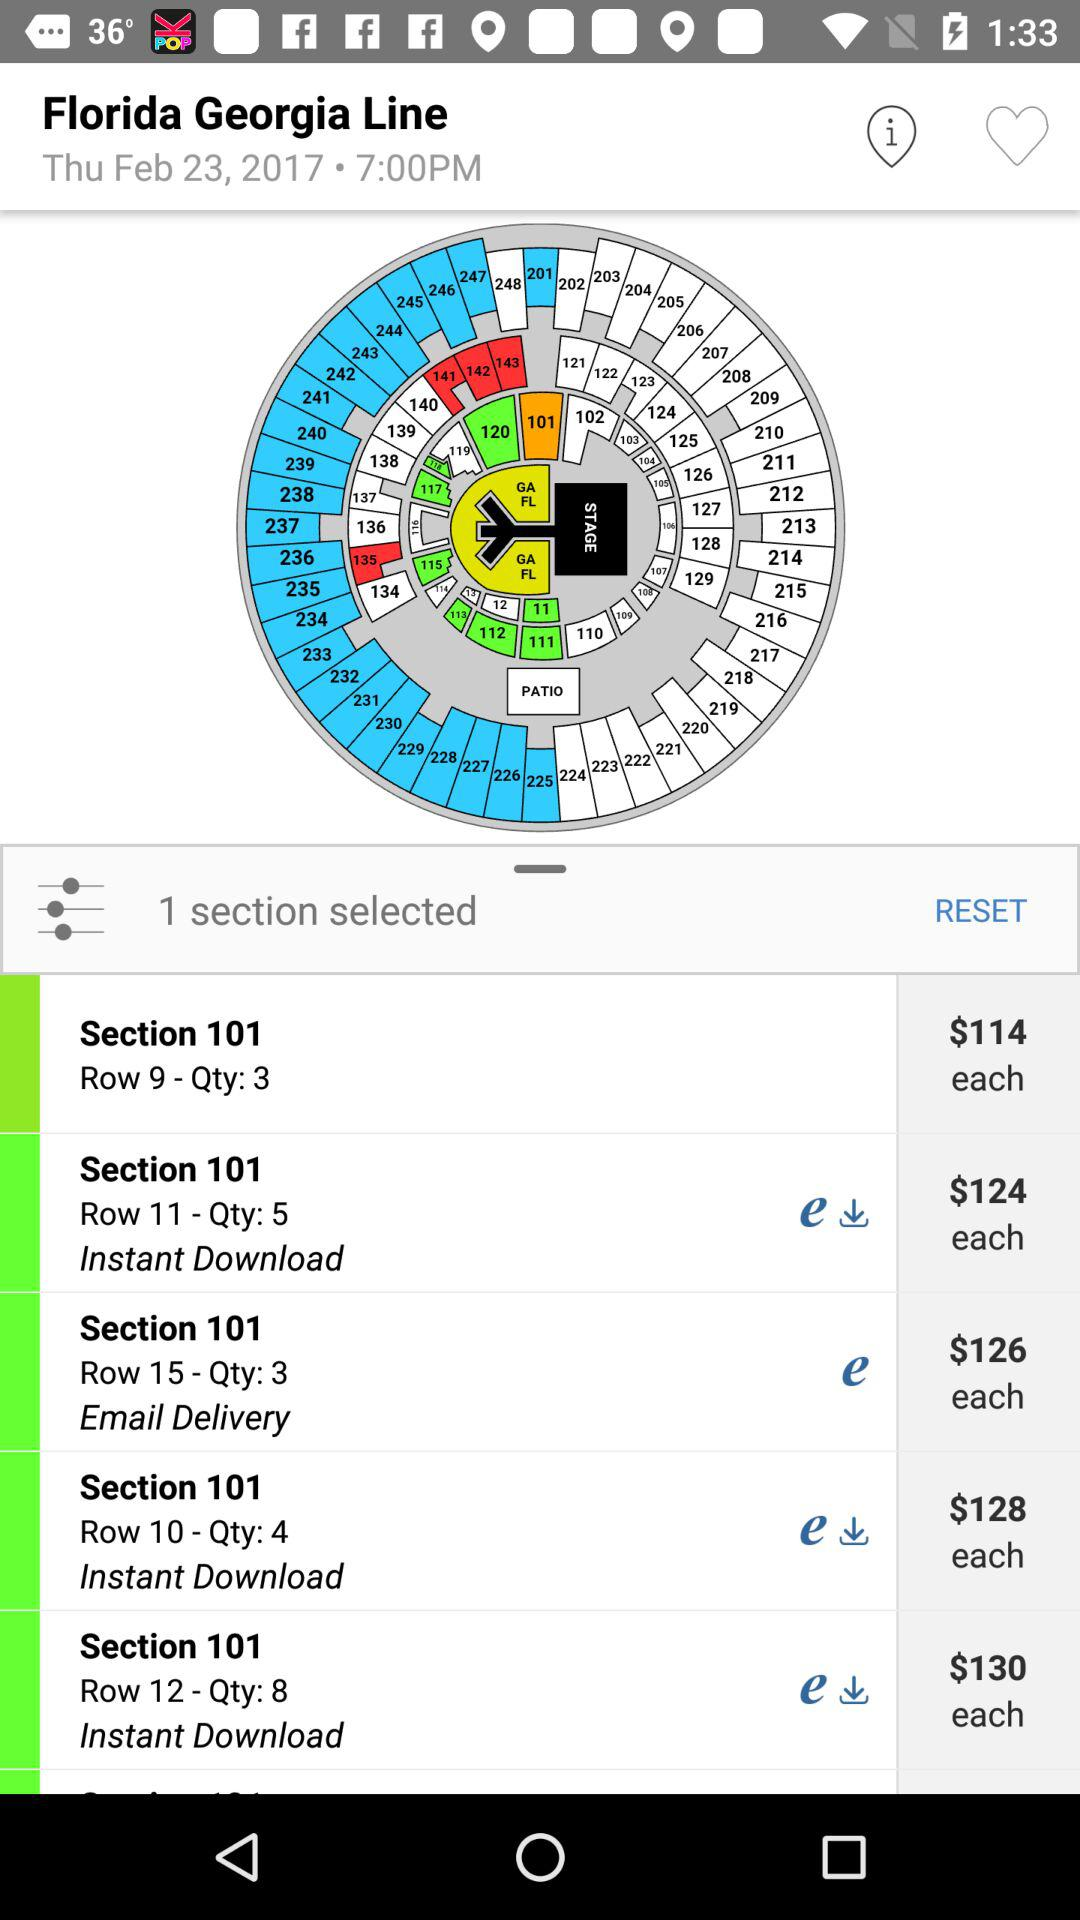How many quantities does Section 101, Row 10 have? Section 101, Row 10 has a quantity of 4. 